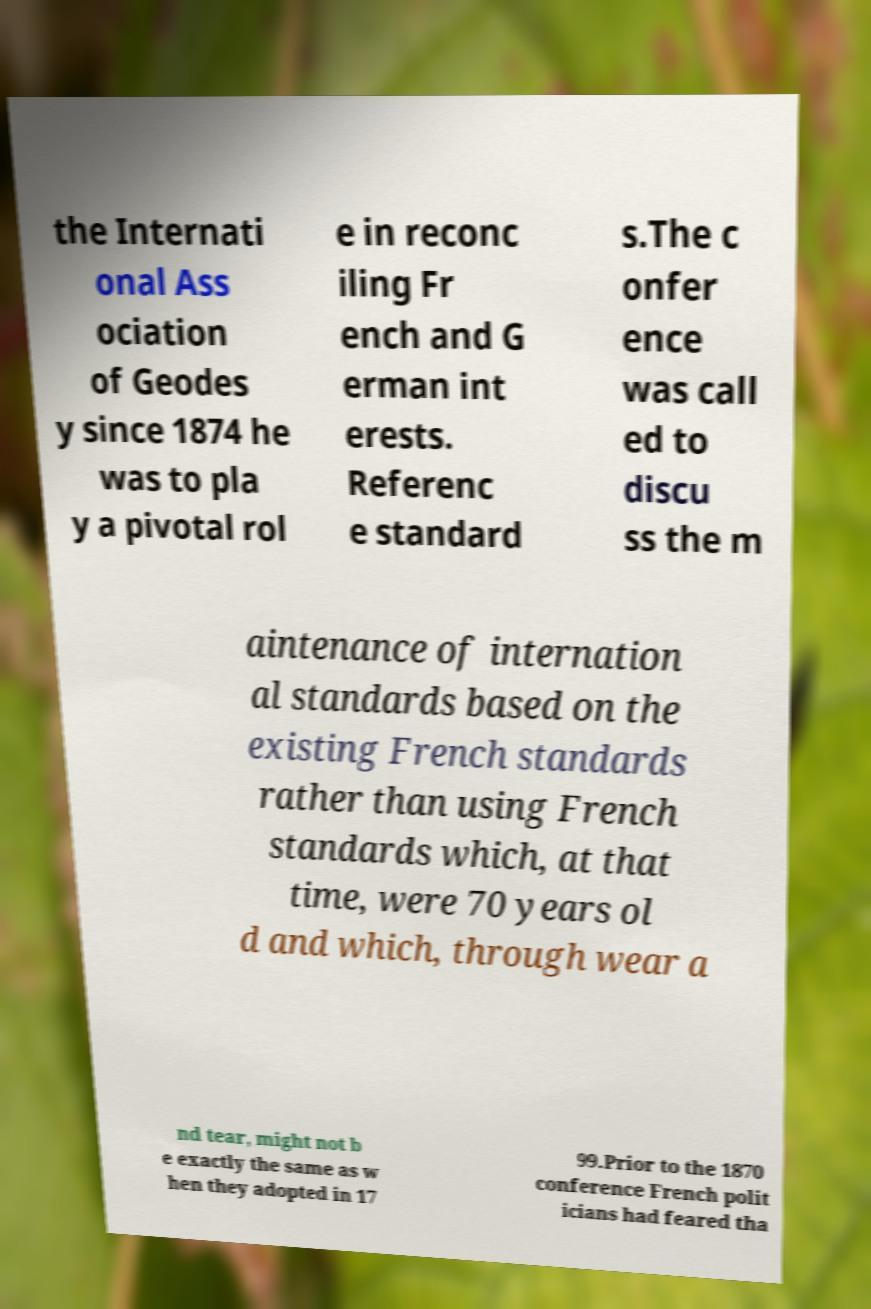Please read and relay the text visible in this image. What does it say? the Internati onal Ass ociation of Geodes y since 1874 he was to pla y a pivotal rol e in reconc iling Fr ench and G erman int erests. Referenc e standard s.The c onfer ence was call ed to discu ss the m aintenance of internation al standards based on the existing French standards rather than using French standards which, at that time, were 70 years ol d and which, through wear a nd tear, might not b e exactly the same as w hen they adopted in 17 99.Prior to the 1870 conference French polit icians had feared tha 